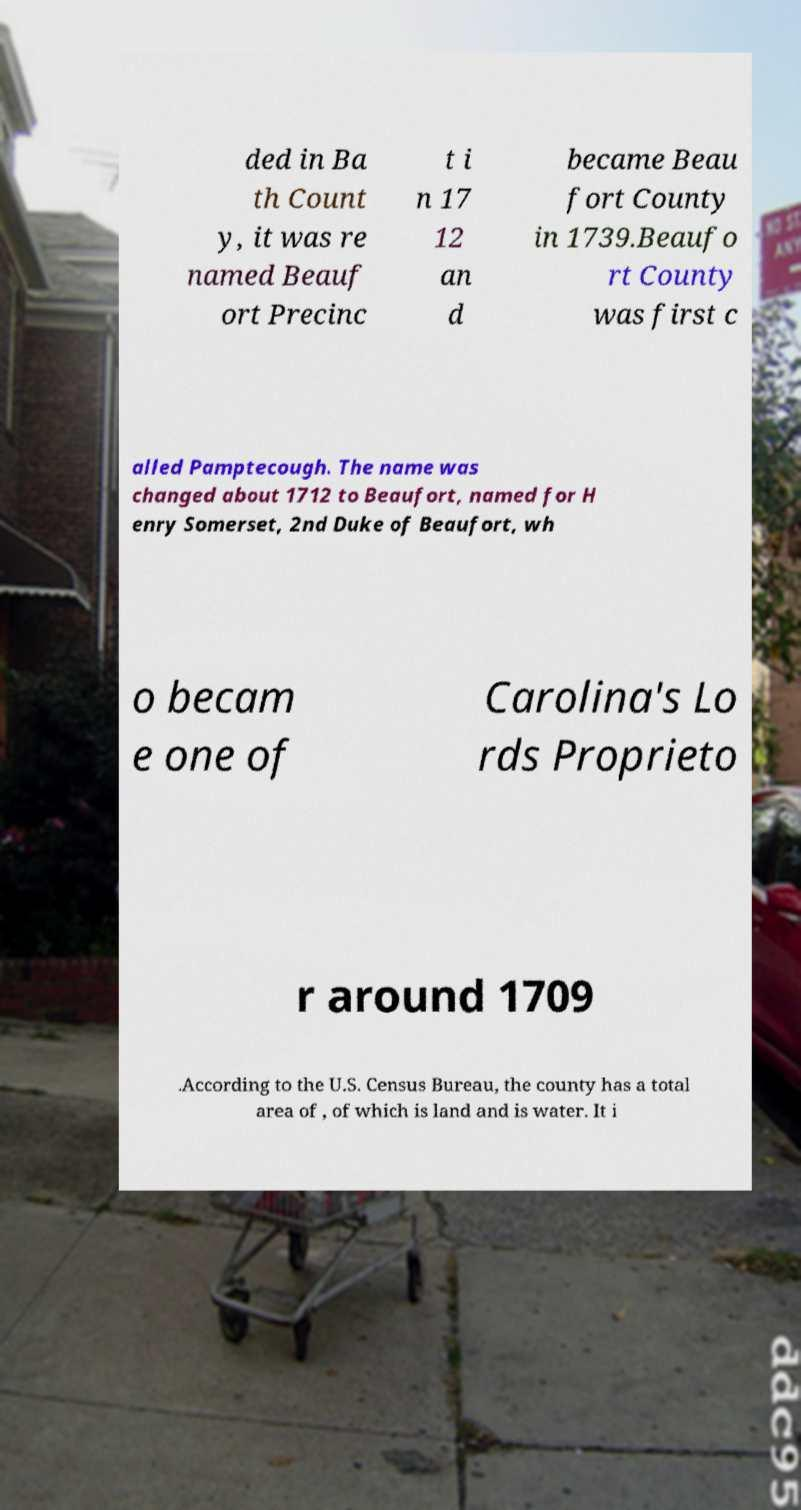Could you extract and type out the text from this image? ded in Ba th Count y, it was re named Beauf ort Precinc t i n 17 12 an d became Beau fort County in 1739.Beaufo rt County was first c alled Pamptecough. The name was changed about 1712 to Beaufort, named for H enry Somerset, 2nd Duke of Beaufort, wh o becam e one of Carolina's Lo rds Proprieto r around 1709 .According to the U.S. Census Bureau, the county has a total area of , of which is land and is water. It i 